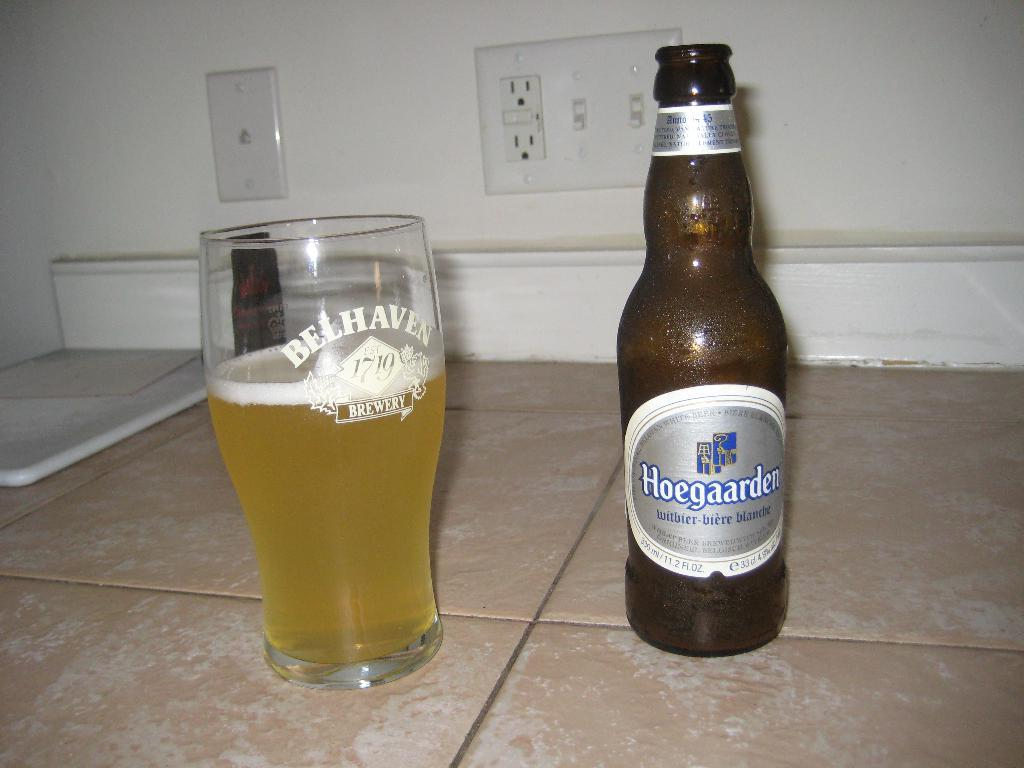<image>
Render a clear and concise summary of the photo. A Belhaven Brewery glass is filled with Hoegaarden beer. 